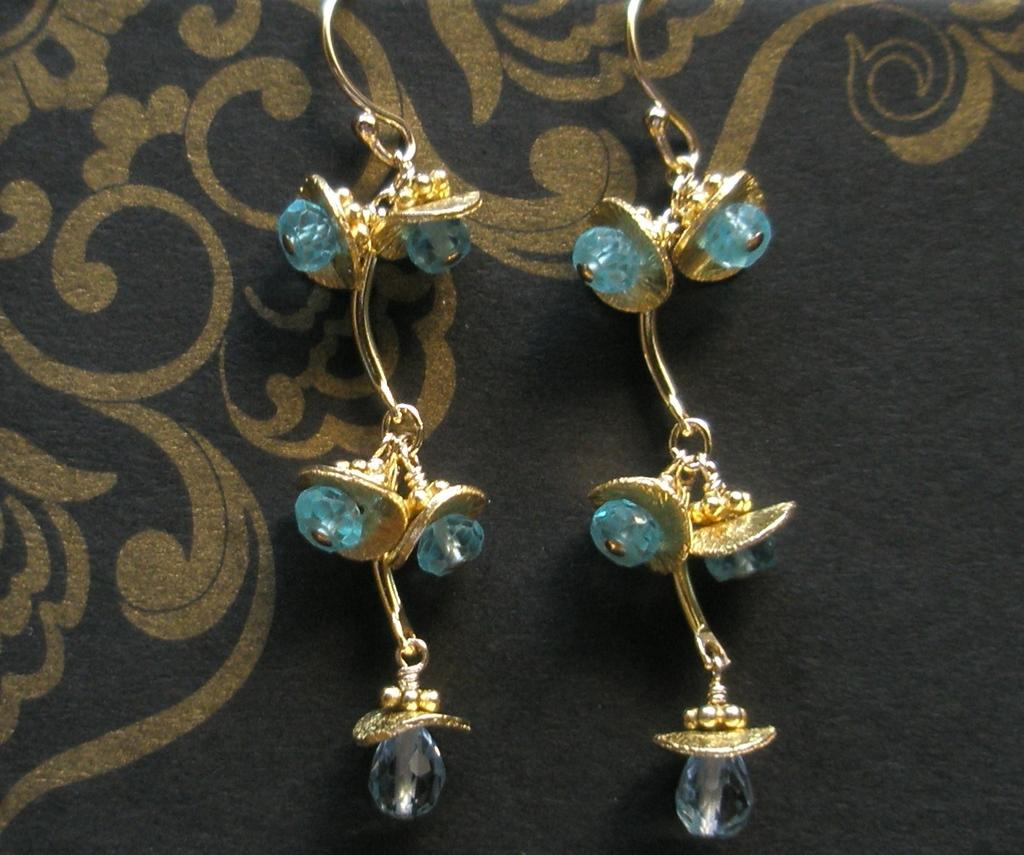What type of accessory is present in the image? There are earrings in the image. Can you describe the surface on which the earrings are placed? The surface the earrings are on is black and golden in color. What type of lamp is visible in the image? There is no lamp present in the image. Can you see an airplane flying in the background of the image? There is no airplane visible in the image. Is there a sail visible in the image? There is no sail present in the image. 